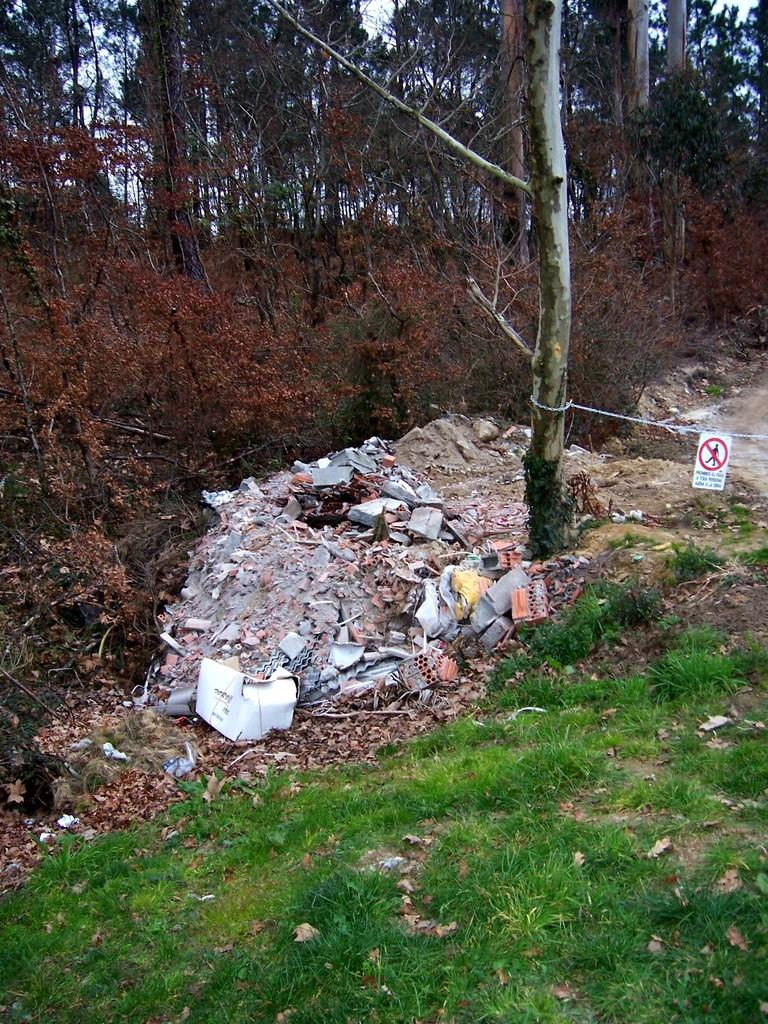What type of ground cover can be seen in the image? There is green grass on the ground in the image. What type of waste is present in the image? There is garbage waste in the image. What type of vegetation is present in the image besides grass? There are trees and plants in the image. What type of apparel is being sold at the store in the image? There is no store or apparel present in the image. What items are on the list that the person is holding in the image? There is no person holding a list in the image. 